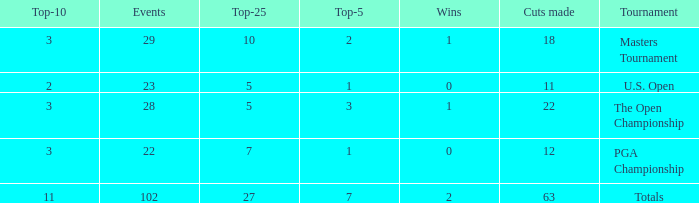How many top 10s when he had under 1 top 5s? None. 